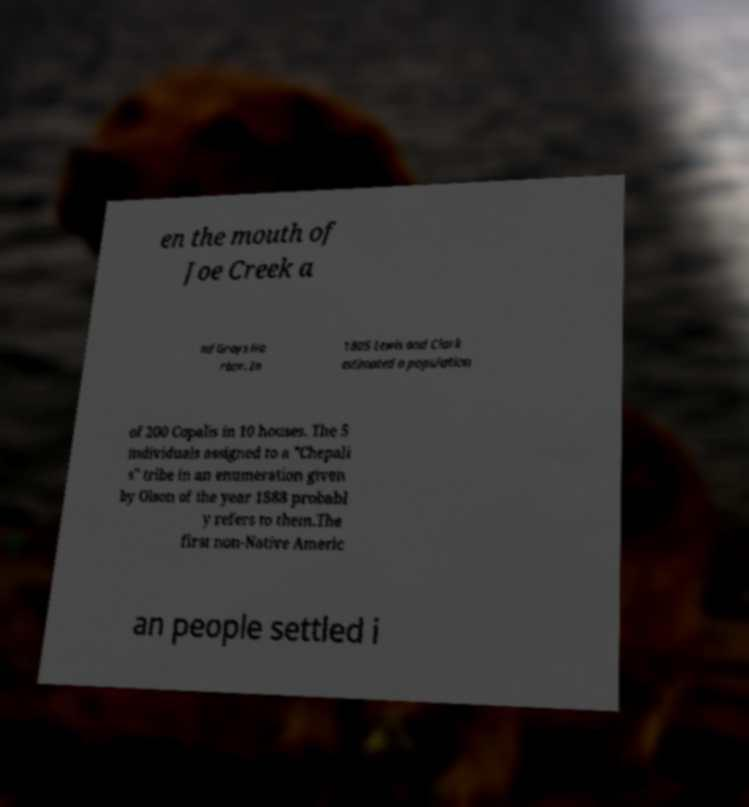Can you accurately transcribe the text from the provided image for me? en the mouth of Joe Creek a nd Grays Ha rbor. In 1805 Lewis and Clark estimated a population of 200 Copalis in 10 houses. The 5 individuals assigned to a "Chepali s" tribe in an enumeration given by Olson of the year 1888 probabl y refers to them.The first non-Native Americ an people settled i 